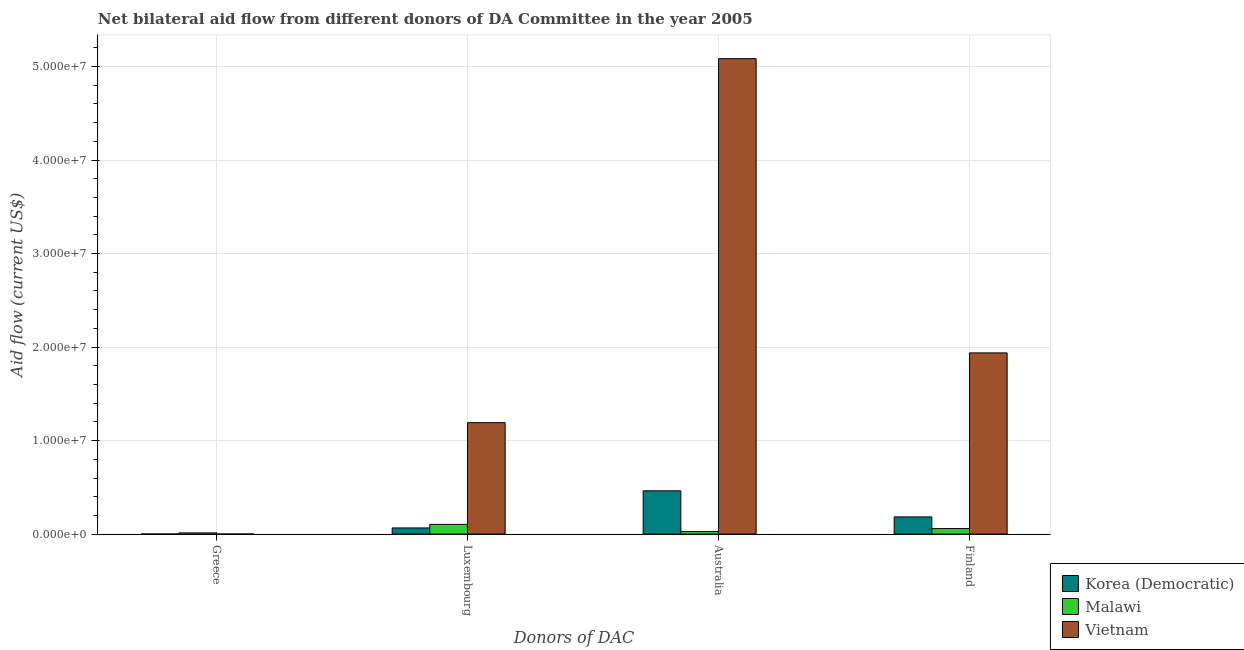How many different coloured bars are there?
Ensure brevity in your answer.  3. Are the number of bars per tick equal to the number of legend labels?
Offer a terse response. Yes. Are the number of bars on each tick of the X-axis equal?
Provide a short and direct response. Yes. What is the amount of aid given by australia in Malawi?
Provide a short and direct response. 2.70e+05. Across all countries, what is the maximum amount of aid given by luxembourg?
Give a very brief answer. 1.19e+07. Across all countries, what is the minimum amount of aid given by finland?
Ensure brevity in your answer.  5.90e+05. In which country was the amount of aid given by finland maximum?
Keep it short and to the point. Vietnam. In which country was the amount of aid given by greece minimum?
Provide a succinct answer. Korea (Democratic). What is the total amount of aid given by luxembourg in the graph?
Provide a succinct answer. 1.36e+07. What is the difference between the amount of aid given by australia in Malawi and that in Vietnam?
Your answer should be compact. -5.06e+07. What is the difference between the amount of aid given by finland in Vietnam and the amount of aid given by greece in Malawi?
Give a very brief answer. 1.92e+07. What is the average amount of aid given by luxembourg per country?
Offer a very short reply. 4.54e+06. What is the difference between the amount of aid given by finland and amount of aid given by luxembourg in Korea (Democratic)?
Offer a terse response. 1.18e+06. In how many countries, is the amount of aid given by finland greater than 20000000 US$?
Your answer should be compact. 0. What is the ratio of the amount of aid given by finland in Malawi to that in Vietnam?
Your response must be concise. 0.03. Is the amount of aid given by finland in Malawi less than that in Vietnam?
Provide a short and direct response. Yes. What is the difference between the highest and the second highest amount of aid given by luxembourg?
Offer a terse response. 1.09e+07. What is the difference between the highest and the lowest amount of aid given by australia?
Offer a terse response. 5.06e+07. In how many countries, is the amount of aid given by australia greater than the average amount of aid given by australia taken over all countries?
Make the answer very short. 1. Is the sum of the amount of aid given by australia in Malawi and Korea (Democratic) greater than the maximum amount of aid given by greece across all countries?
Your response must be concise. Yes. Is it the case that in every country, the sum of the amount of aid given by australia and amount of aid given by luxembourg is greater than the sum of amount of aid given by finland and amount of aid given by greece?
Offer a very short reply. No. What does the 2nd bar from the left in Greece represents?
Give a very brief answer. Malawi. What does the 1st bar from the right in Finland represents?
Keep it short and to the point. Vietnam. How many countries are there in the graph?
Keep it short and to the point. 3. What is the difference between two consecutive major ticks on the Y-axis?
Give a very brief answer. 1.00e+07. Are the values on the major ticks of Y-axis written in scientific E-notation?
Your answer should be very brief. Yes. Does the graph contain grids?
Make the answer very short. Yes. How are the legend labels stacked?
Give a very brief answer. Vertical. What is the title of the graph?
Provide a succinct answer. Net bilateral aid flow from different donors of DA Committee in the year 2005. Does "Lebanon" appear as one of the legend labels in the graph?
Keep it short and to the point. No. What is the label or title of the X-axis?
Your answer should be compact. Donors of DAC. What is the Aid flow (current US$) of Korea (Democratic) in Greece?
Ensure brevity in your answer.  10000. What is the Aid flow (current US$) of Malawi in Greece?
Offer a terse response. 1.30e+05. What is the Aid flow (current US$) of Vietnam in Greece?
Your response must be concise. 10000. What is the Aid flow (current US$) in Korea (Democratic) in Luxembourg?
Offer a terse response. 6.60e+05. What is the Aid flow (current US$) in Malawi in Luxembourg?
Keep it short and to the point. 1.04e+06. What is the Aid flow (current US$) of Vietnam in Luxembourg?
Offer a very short reply. 1.19e+07. What is the Aid flow (current US$) of Korea (Democratic) in Australia?
Keep it short and to the point. 4.63e+06. What is the Aid flow (current US$) in Malawi in Australia?
Give a very brief answer. 2.70e+05. What is the Aid flow (current US$) in Vietnam in Australia?
Your answer should be compact. 5.08e+07. What is the Aid flow (current US$) of Korea (Democratic) in Finland?
Offer a very short reply. 1.84e+06. What is the Aid flow (current US$) of Malawi in Finland?
Ensure brevity in your answer.  5.90e+05. What is the Aid flow (current US$) in Vietnam in Finland?
Your answer should be compact. 1.94e+07. Across all Donors of DAC, what is the maximum Aid flow (current US$) in Korea (Democratic)?
Offer a terse response. 4.63e+06. Across all Donors of DAC, what is the maximum Aid flow (current US$) of Malawi?
Provide a succinct answer. 1.04e+06. Across all Donors of DAC, what is the maximum Aid flow (current US$) of Vietnam?
Give a very brief answer. 5.08e+07. What is the total Aid flow (current US$) in Korea (Democratic) in the graph?
Your response must be concise. 7.14e+06. What is the total Aid flow (current US$) in Malawi in the graph?
Your answer should be compact. 2.03e+06. What is the total Aid flow (current US$) in Vietnam in the graph?
Offer a very short reply. 8.22e+07. What is the difference between the Aid flow (current US$) of Korea (Democratic) in Greece and that in Luxembourg?
Provide a short and direct response. -6.50e+05. What is the difference between the Aid flow (current US$) in Malawi in Greece and that in Luxembourg?
Keep it short and to the point. -9.10e+05. What is the difference between the Aid flow (current US$) in Vietnam in Greece and that in Luxembourg?
Provide a succinct answer. -1.19e+07. What is the difference between the Aid flow (current US$) of Korea (Democratic) in Greece and that in Australia?
Provide a succinct answer. -4.62e+06. What is the difference between the Aid flow (current US$) in Vietnam in Greece and that in Australia?
Ensure brevity in your answer.  -5.08e+07. What is the difference between the Aid flow (current US$) of Korea (Democratic) in Greece and that in Finland?
Offer a terse response. -1.83e+06. What is the difference between the Aid flow (current US$) of Malawi in Greece and that in Finland?
Offer a terse response. -4.60e+05. What is the difference between the Aid flow (current US$) of Vietnam in Greece and that in Finland?
Your response must be concise. -1.94e+07. What is the difference between the Aid flow (current US$) of Korea (Democratic) in Luxembourg and that in Australia?
Make the answer very short. -3.97e+06. What is the difference between the Aid flow (current US$) of Malawi in Luxembourg and that in Australia?
Give a very brief answer. 7.70e+05. What is the difference between the Aid flow (current US$) in Vietnam in Luxembourg and that in Australia?
Your answer should be very brief. -3.89e+07. What is the difference between the Aid flow (current US$) in Korea (Democratic) in Luxembourg and that in Finland?
Make the answer very short. -1.18e+06. What is the difference between the Aid flow (current US$) of Vietnam in Luxembourg and that in Finland?
Your answer should be very brief. -7.46e+06. What is the difference between the Aid flow (current US$) in Korea (Democratic) in Australia and that in Finland?
Offer a very short reply. 2.79e+06. What is the difference between the Aid flow (current US$) in Malawi in Australia and that in Finland?
Make the answer very short. -3.20e+05. What is the difference between the Aid flow (current US$) in Vietnam in Australia and that in Finland?
Your answer should be very brief. 3.15e+07. What is the difference between the Aid flow (current US$) of Korea (Democratic) in Greece and the Aid flow (current US$) of Malawi in Luxembourg?
Offer a very short reply. -1.03e+06. What is the difference between the Aid flow (current US$) of Korea (Democratic) in Greece and the Aid flow (current US$) of Vietnam in Luxembourg?
Your answer should be very brief. -1.19e+07. What is the difference between the Aid flow (current US$) of Malawi in Greece and the Aid flow (current US$) of Vietnam in Luxembourg?
Keep it short and to the point. -1.18e+07. What is the difference between the Aid flow (current US$) in Korea (Democratic) in Greece and the Aid flow (current US$) in Vietnam in Australia?
Offer a very short reply. -5.08e+07. What is the difference between the Aid flow (current US$) in Malawi in Greece and the Aid flow (current US$) in Vietnam in Australia?
Your answer should be compact. -5.07e+07. What is the difference between the Aid flow (current US$) of Korea (Democratic) in Greece and the Aid flow (current US$) of Malawi in Finland?
Offer a terse response. -5.80e+05. What is the difference between the Aid flow (current US$) of Korea (Democratic) in Greece and the Aid flow (current US$) of Vietnam in Finland?
Give a very brief answer. -1.94e+07. What is the difference between the Aid flow (current US$) in Malawi in Greece and the Aid flow (current US$) in Vietnam in Finland?
Provide a succinct answer. -1.92e+07. What is the difference between the Aid flow (current US$) in Korea (Democratic) in Luxembourg and the Aid flow (current US$) in Vietnam in Australia?
Your response must be concise. -5.02e+07. What is the difference between the Aid flow (current US$) in Malawi in Luxembourg and the Aid flow (current US$) in Vietnam in Australia?
Your answer should be compact. -4.98e+07. What is the difference between the Aid flow (current US$) of Korea (Democratic) in Luxembourg and the Aid flow (current US$) of Vietnam in Finland?
Provide a short and direct response. -1.87e+07. What is the difference between the Aid flow (current US$) of Malawi in Luxembourg and the Aid flow (current US$) of Vietnam in Finland?
Offer a very short reply. -1.83e+07. What is the difference between the Aid flow (current US$) of Korea (Democratic) in Australia and the Aid flow (current US$) of Malawi in Finland?
Your answer should be very brief. 4.04e+06. What is the difference between the Aid flow (current US$) of Korea (Democratic) in Australia and the Aid flow (current US$) of Vietnam in Finland?
Your answer should be compact. -1.48e+07. What is the difference between the Aid flow (current US$) of Malawi in Australia and the Aid flow (current US$) of Vietnam in Finland?
Your response must be concise. -1.91e+07. What is the average Aid flow (current US$) in Korea (Democratic) per Donors of DAC?
Offer a very short reply. 1.78e+06. What is the average Aid flow (current US$) of Malawi per Donors of DAC?
Ensure brevity in your answer.  5.08e+05. What is the average Aid flow (current US$) in Vietnam per Donors of DAC?
Provide a succinct answer. 2.05e+07. What is the difference between the Aid flow (current US$) in Malawi and Aid flow (current US$) in Vietnam in Greece?
Give a very brief answer. 1.20e+05. What is the difference between the Aid flow (current US$) in Korea (Democratic) and Aid flow (current US$) in Malawi in Luxembourg?
Keep it short and to the point. -3.80e+05. What is the difference between the Aid flow (current US$) in Korea (Democratic) and Aid flow (current US$) in Vietnam in Luxembourg?
Your response must be concise. -1.13e+07. What is the difference between the Aid flow (current US$) of Malawi and Aid flow (current US$) of Vietnam in Luxembourg?
Keep it short and to the point. -1.09e+07. What is the difference between the Aid flow (current US$) of Korea (Democratic) and Aid flow (current US$) of Malawi in Australia?
Give a very brief answer. 4.36e+06. What is the difference between the Aid flow (current US$) in Korea (Democratic) and Aid flow (current US$) in Vietnam in Australia?
Your answer should be compact. -4.62e+07. What is the difference between the Aid flow (current US$) in Malawi and Aid flow (current US$) in Vietnam in Australia?
Offer a very short reply. -5.06e+07. What is the difference between the Aid flow (current US$) of Korea (Democratic) and Aid flow (current US$) of Malawi in Finland?
Give a very brief answer. 1.25e+06. What is the difference between the Aid flow (current US$) of Korea (Democratic) and Aid flow (current US$) of Vietnam in Finland?
Ensure brevity in your answer.  -1.75e+07. What is the difference between the Aid flow (current US$) of Malawi and Aid flow (current US$) of Vietnam in Finland?
Your answer should be compact. -1.88e+07. What is the ratio of the Aid flow (current US$) in Korea (Democratic) in Greece to that in Luxembourg?
Offer a terse response. 0.02. What is the ratio of the Aid flow (current US$) in Vietnam in Greece to that in Luxembourg?
Your answer should be compact. 0. What is the ratio of the Aid flow (current US$) in Korea (Democratic) in Greece to that in Australia?
Your answer should be compact. 0. What is the ratio of the Aid flow (current US$) of Malawi in Greece to that in Australia?
Your response must be concise. 0.48. What is the ratio of the Aid flow (current US$) in Vietnam in Greece to that in Australia?
Your answer should be compact. 0. What is the ratio of the Aid flow (current US$) in Korea (Democratic) in Greece to that in Finland?
Make the answer very short. 0.01. What is the ratio of the Aid flow (current US$) of Malawi in Greece to that in Finland?
Offer a terse response. 0.22. What is the ratio of the Aid flow (current US$) of Korea (Democratic) in Luxembourg to that in Australia?
Make the answer very short. 0.14. What is the ratio of the Aid flow (current US$) in Malawi in Luxembourg to that in Australia?
Provide a short and direct response. 3.85. What is the ratio of the Aid flow (current US$) in Vietnam in Luxembourg to that in Australia?
Provide a succinct answer. 0.23. What is the ratio of the Aid flow (current US$) in Korea (Democratic) in Luxembourg to that in Finland?
Your response must be concise. 0.36. What is the ratio of the Aid flow (current US$) of Malawi in Luxembourg to that in Finland?
Make the answer very short. 1.76. What is the ratio of the Aid flow (current US$) in Vietnam in Luxembourg to that in Finland?
Your answer should be compact. 0.62. What is the ratio of the Aid flow (current US$) of Korea (Democratic) in Australia to that in Finland?
Offer a terse response. 2.52. What is the ratio of the Aid flow (current US$) in Malawi in Australia to that in Finland?
Your answer should be compact. 0.46. What is the ratio of the Aid flow (current US$) in Vietnam in Australia to that in Finland?
Provide a succinct answer. 2.62. What is the difference between the highest and the second highest Aid flow (current US$) of Korea (Democratic)?
Offer a very short reply. 2.79e+06. What is the difference between the highest and the second highest Aid flow (current US$) in Malawi?
Ensure brevity in your answer.  4.50e+05. What is the difference between the highest and the second highest Aid flow (current US$) in Vietnam?
Provide a short and direct response. 3.15e+07. What is the difference between the highest and the lowest Aid flow (current US$) in Korea (Democratic)?
Offer a very short reply. 4.62e+06. What is the difference between the highest and the lowest Aid flow (current US$) of Malawi?
Offer a terse response. 9.10e+05. What is the difference between the highest and the lowest Aid flow (current US$) of Vietnam?
Your answer should be compact. 5.08e+07. 